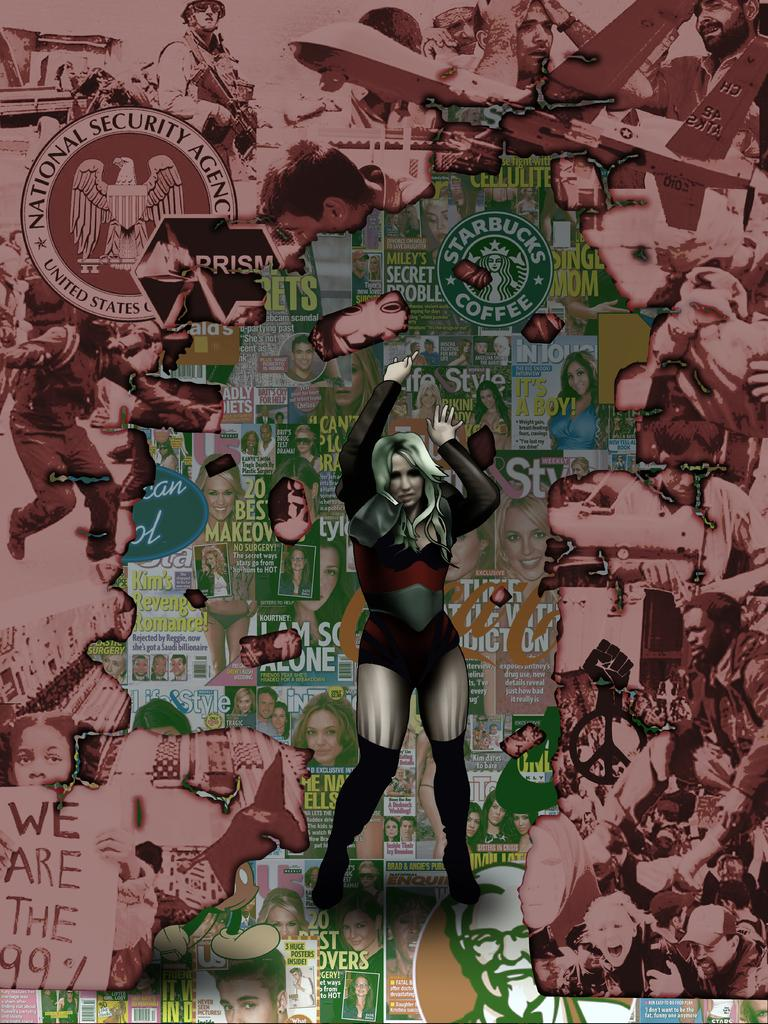<image>
Give a short and clear explanation of the subsequent image. Starbucks coffee is advertised on the poster with the girl pictured. 